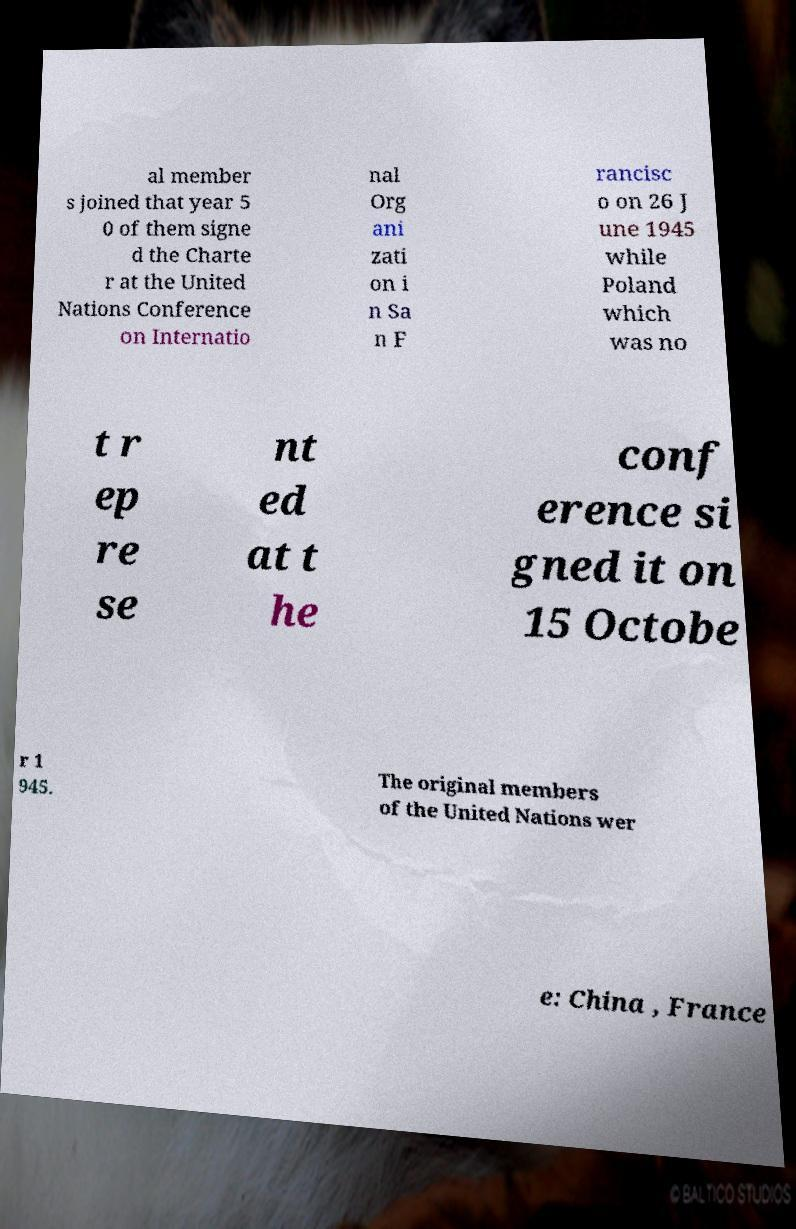Please read and relay the text visible in this image. What does it say? al member s joined that year 5 0 of them signe d the Charte r at the United Nations Conference on Internatio nal Org ani zati on i n Sa n F rancisc o on 26 J une 1945 while Poland which was no t r ep re se nt ed at t he conf erence si gned it on 15 Octobe r 1 945. The original members of the United Nations wer e: China , France 